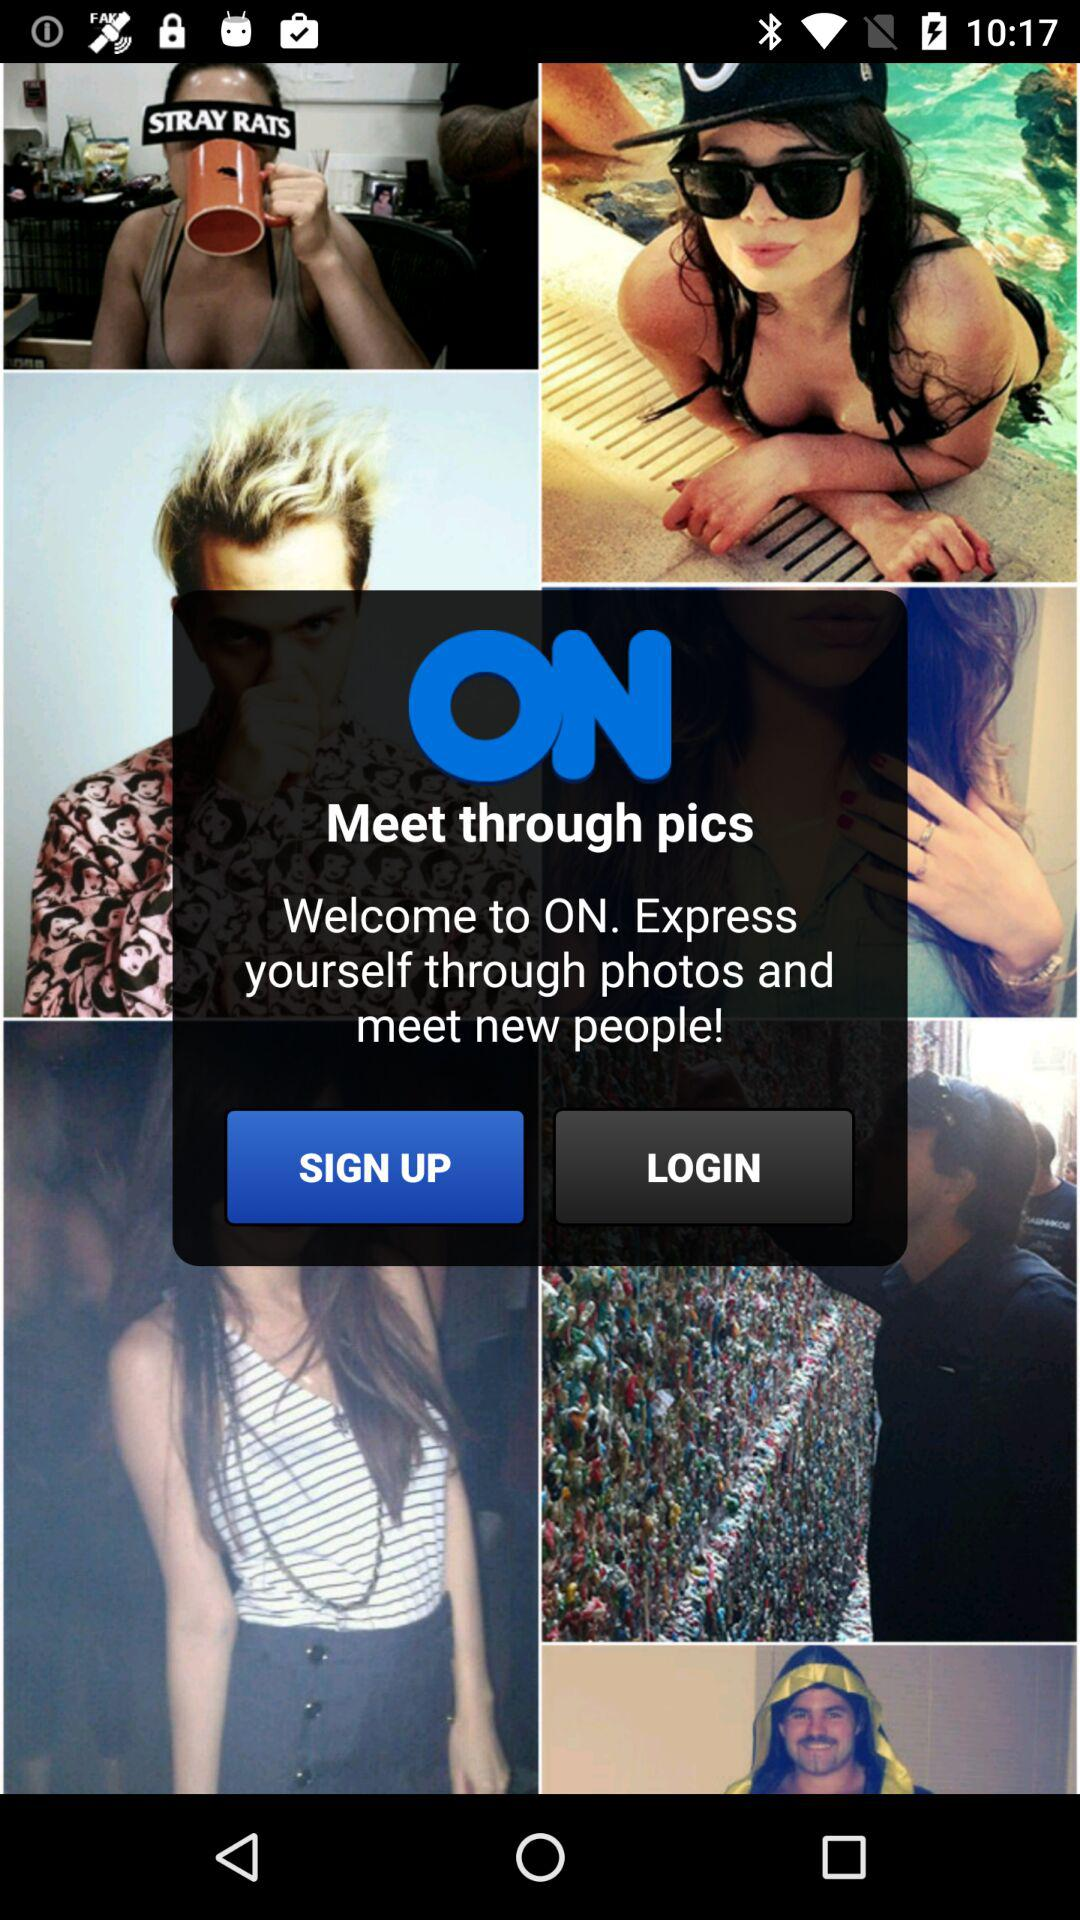What is the application name? The application name is "ON". 